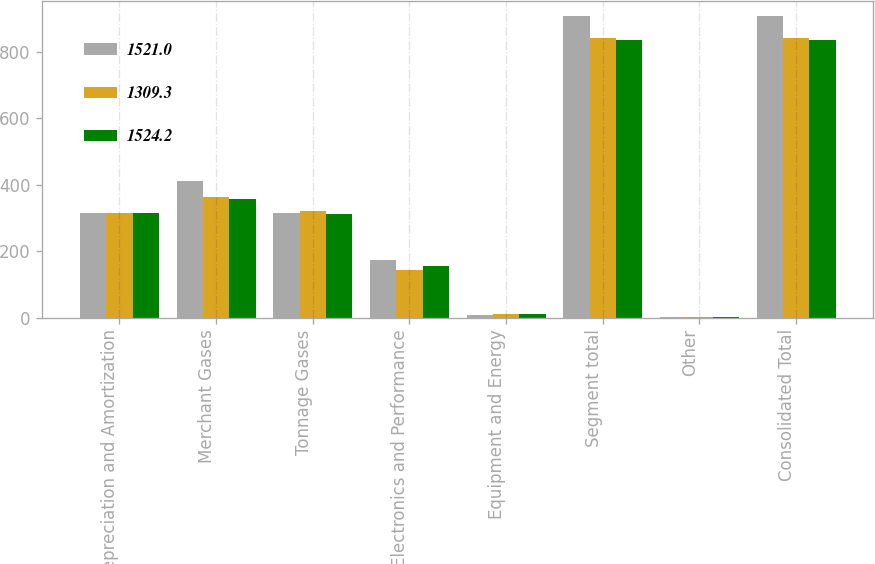<chart> <loc_0><loc_0><loc_500><loc_500><stacked_bar_chart><ecel><fcel>Depreciation and Amortization<fcel>Merchant Gases<fcel>Tonnage Gases<fcel>Electronics and Performance<fcel>Equipment and Energy<fcel>Segment total<fcel>Other<fcel>Consolidated Total<nl><fcel>1521<fcel>314.8<fcel>409.5<fcel>314.8<fcel>173.4<fcel>8.3<fcel>906<fcel>1<fcel>907<nl><fcel>1309.3<fcel>314.8<fcel>363.2<fcel>320.4<fcel>144.1<fcel>12.2<fcel>839.9<fcel>0.9<fcel>840.8<nl><fcel>1524.2<fcel>314.8<fcel>356.9<fcel>310.9<fcel>154.9<fcel>11<fcel>833.7<fcel>0.6<fcel>834.3<nl></chart> 